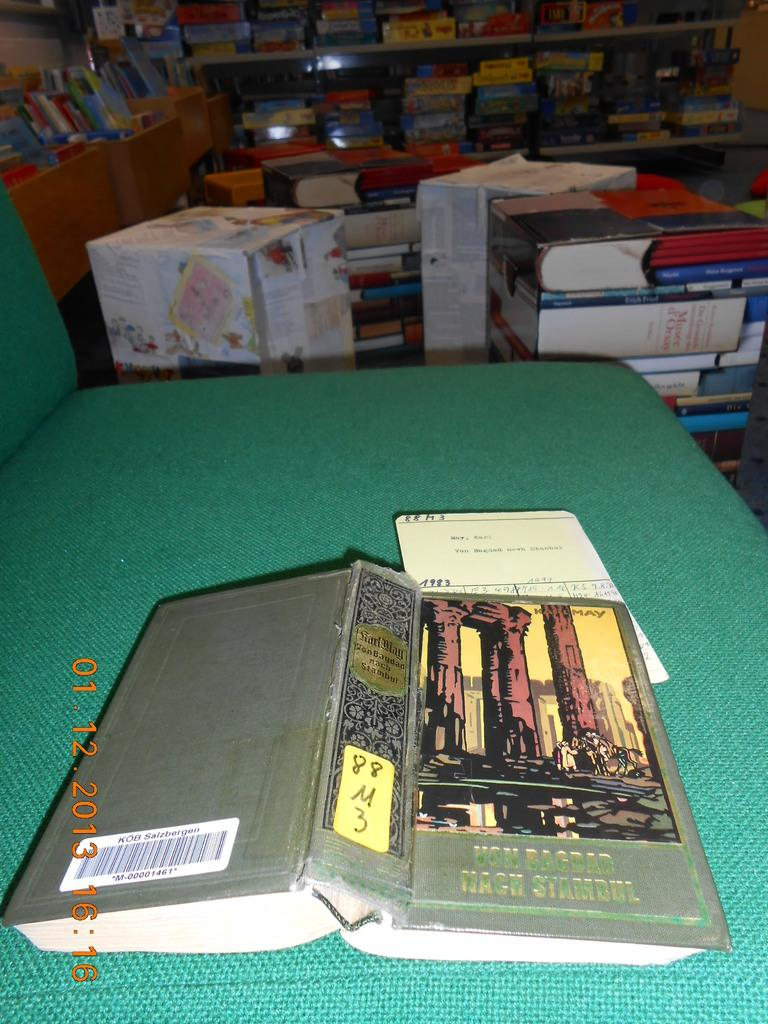<image>
Create a compact narrative representing the image presented. Book facing downwards showing the cover of "Von Bagdad". 